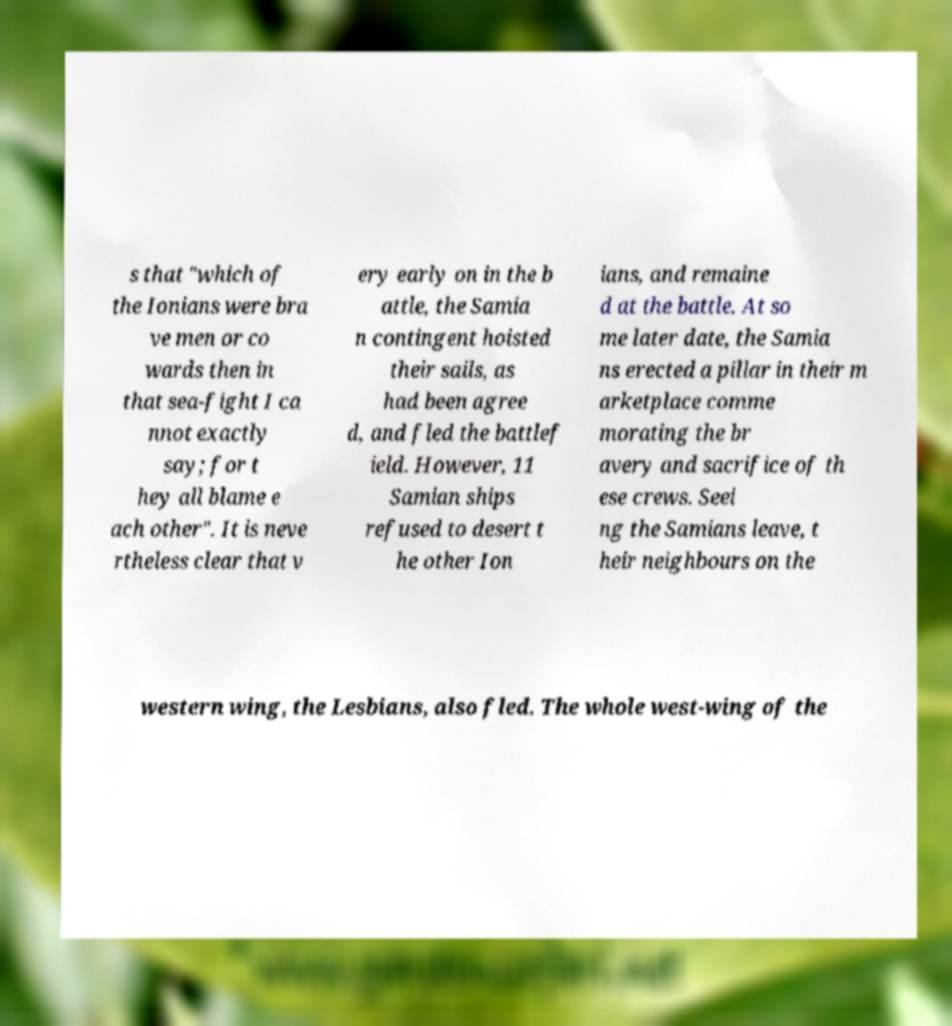Can you accurately transcribe the text from the provided image for me? s that "which of the Ionians were bra ve men or co wards then in that sea-fight I ca nnot exactly say; for t hey all blame e ach other". It is neve rtheless clear that v ery early on in the b attle, the Samia n contingent hoisted their sails, as had been agree d, and fled the battlef ield. However, 11 Samian ships refused to desert t he other Ion ians, and remaine d at the battle. At so me later date, the Samia ns erected a pillar in their m arketplace comme morating the br avery and sacrifice of th ese crews. Seei ng the Samians leave, t heir neighbours on the western wing, the Lesbians, also fled. The whole west-wing of the 